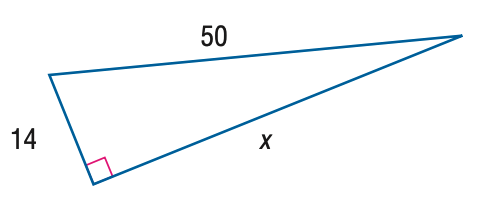Question: Find x.
Choices:
A. 42
B. 44
C. 46
D. 48
Answer with the letter. Answer: D 